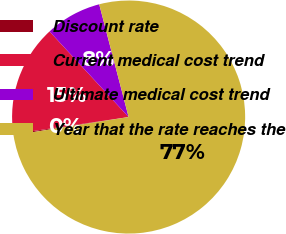Convert chart. <chart><loc_0><loc_0><loc_500><loc_500><pie_chart><fcel>Discount rate<fcel>Current medical cost trend<fcel>Ultimate medical cost trend<fcel>Year that the rate reaches the<nl><fcel>0.17%<fcel>15.45%<fcel>7.81%<fcel>76.57%<nl></chart> 